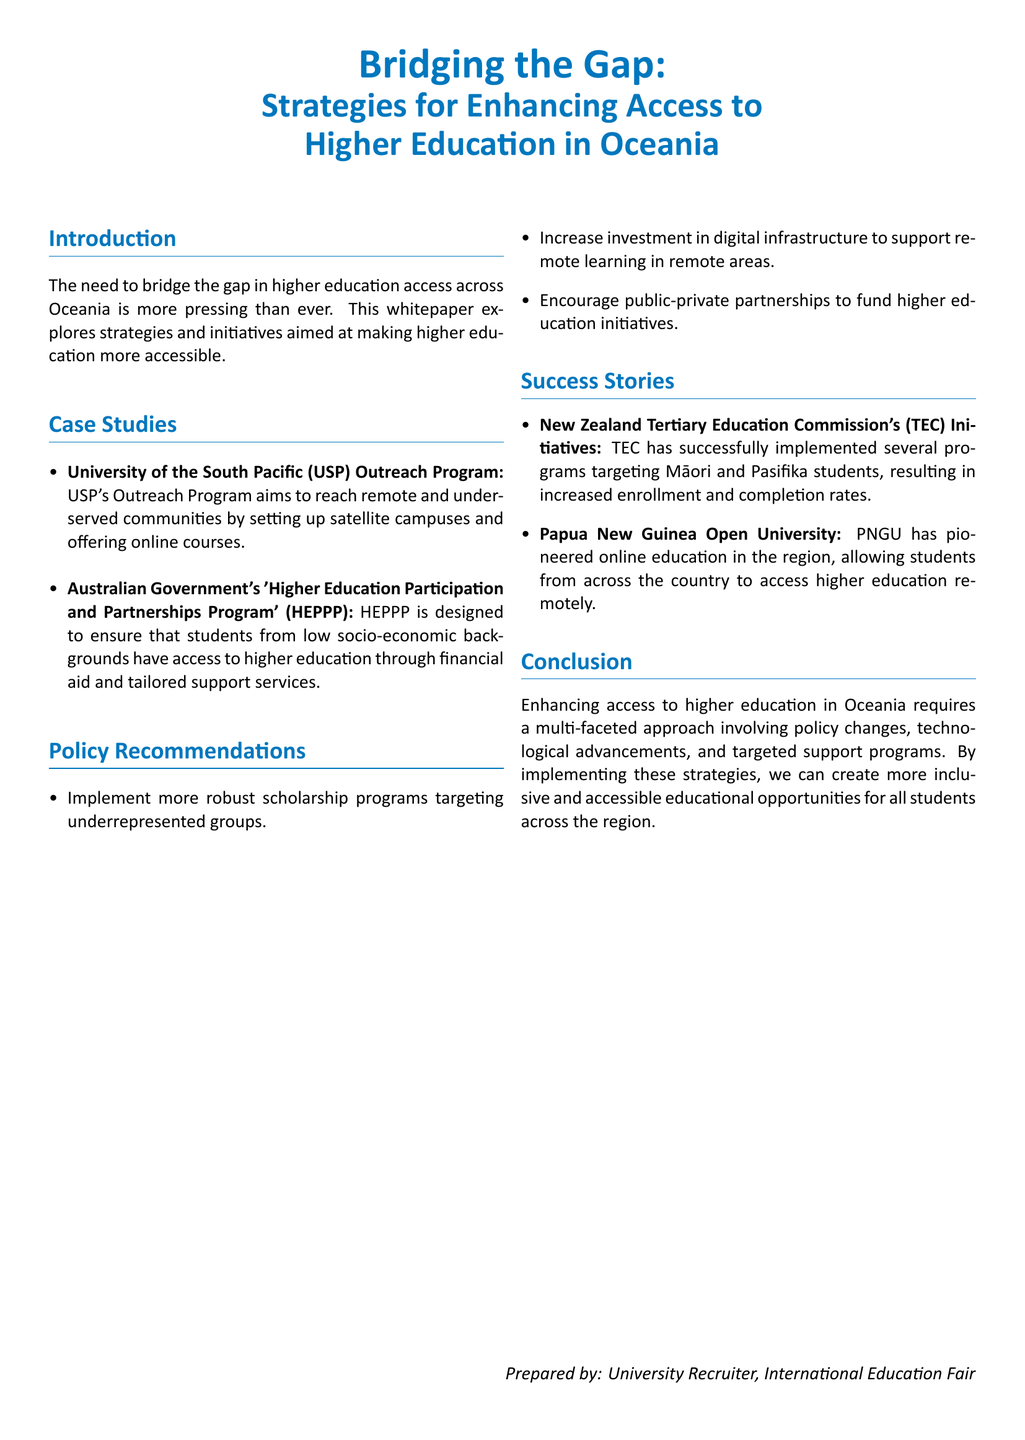What is the title of the whitepaper? The title is clearly stated at the beginning of the document and is "Bridging the Gap: Strategies for Enhancing Access to Higher Education in Oceania."
Answer: Bridging the Gap: Strategies for Enhancing Access to Higher Education in Oceania What are the two main case studies mentioned? The document lists two key case studies in the case studies section: the University of the South Pacific's Outreach Program and the Australian Government's HEPPP.
Answer: University of the South Pacific (USP) Outreach Program, Australian Government's HEPPP How many policy recommendations are provided? The document presents a list of three policy recommendations under its specific section.
Answer: Three Which organization implemented successful programs targeting Māori and Pasifika students? The success stories section credits the New Zealand Tertiary Education Commission with implementing these programs.
Answer: New Zealand Tertiary Education Commission What is one strategy to bridge the gap in higher education access? A strategy mentioned in the policy recommendations includes implementing more robust scholarship programs targeting underrepresented groups.
Answer: Implement more robust scholarship programs What role does technology play in enhancing education access according to the document? The document emphasizes the need to increase investment in digital infrastructure to support remote learning in remote areas, highlighting technology as a key factor.
Answer: Increase investment in digital infrastructure Who is the document prepared by? The final section reveals the document is prepared by a university recruiter at an international education fair.
Answer: University Recruiter, International Education Fair 